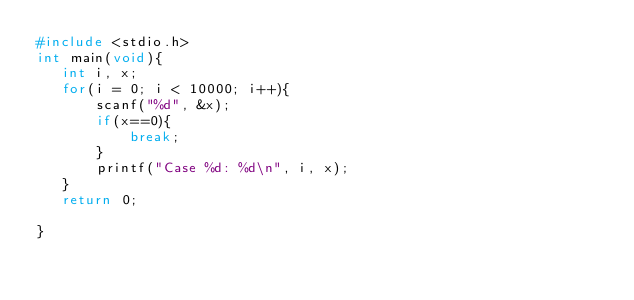<code> <loc_0><loc_0><loc_500><loc_500><_C_>#include <stdio.h>
int main(void){
   int i, x;
   for(i = 0; i < 10000; i++){
       scanf("%d", &x);
       if(x==0){
           break;
       }
       printf("Case %d: %d\n", i, x);
   }
   return 0;
    
}

</code> 